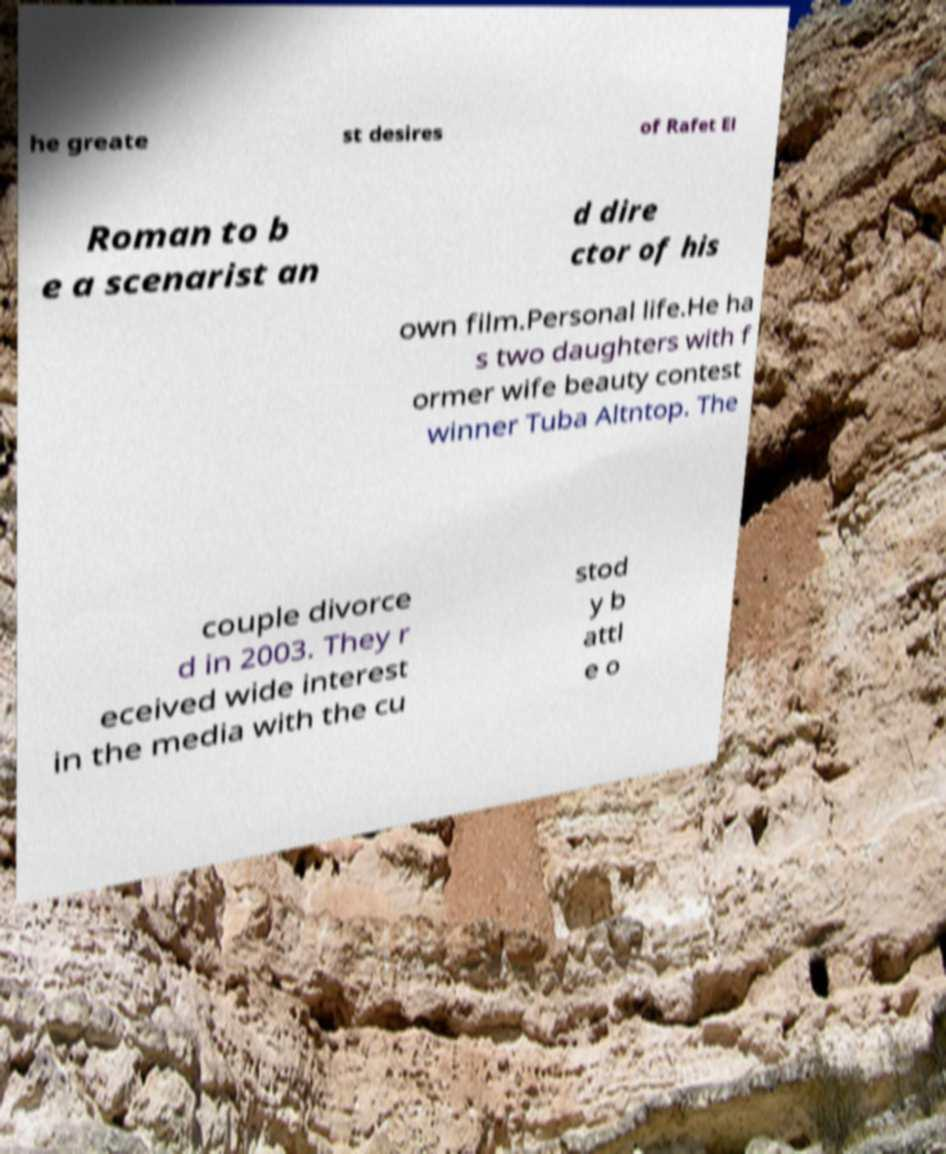For documentation purposes, I need the text within this image transcribed. Could you provide that? he greate st desires of Rafet El Roman to b e a scenarist an d dire ctor of his own film.Personal life.He ha s two daughters with f ormer wife beauty contest winner Tuba Altntop. The couple divorce d in 2003. They r eceived wide interest in the media with the cu stod y b attl e o 